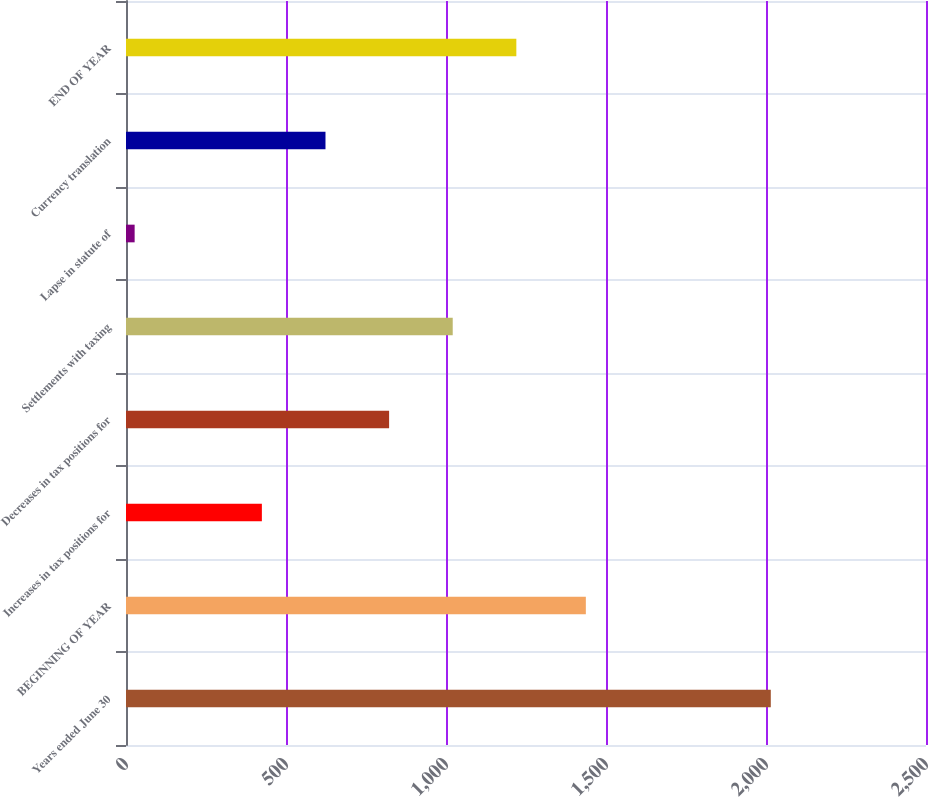Convert chart to OTSL. <chart><loc_0><loc_0><loc_500><loc_500><bar_chart><fcel>Years ended June 30<fcel>BEGINNING OF YEAR<fcel>Increases in tax positions for<fcel>Decreases in tax positions for<fcel>Settlements with taxing<fcel>Lapse in statute of<fcel>Currency translation<fcel>END OF YEAR<nl><fcel>2015<fcel>1437<fcel>424.6<fcel>822.2<fcel>1021<fcel>27<fcel>623.4<fcel>1219.8<nl></chart> 